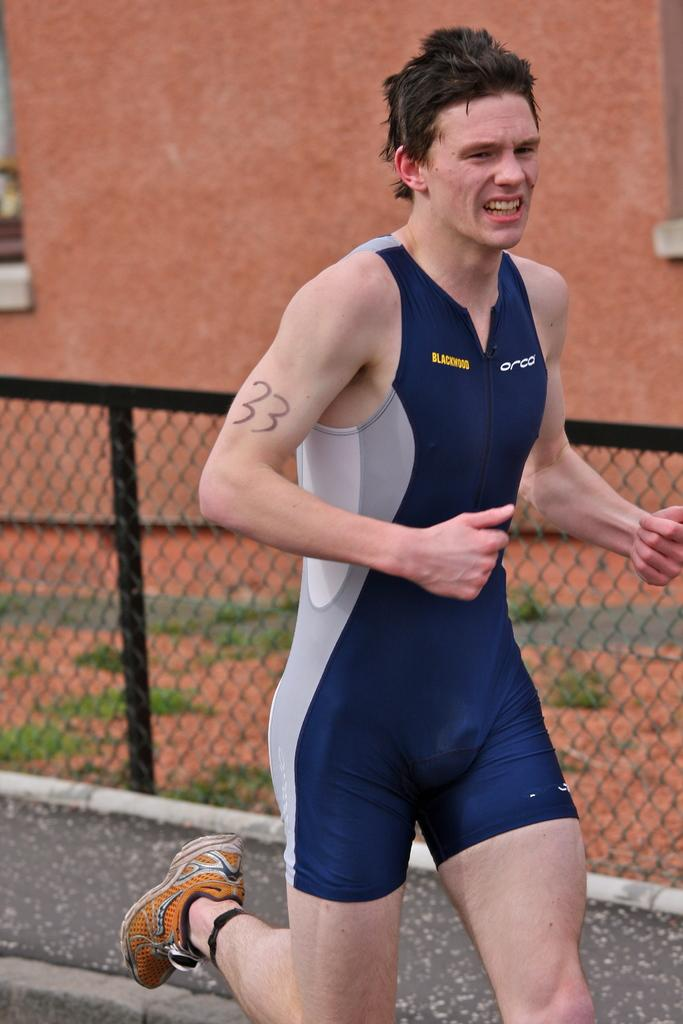What is the main subject in the image? There is a person standing on the road. What can be seen in the background of the image? There is a building behind the person. Where is the lake located in the image? There is no lake present in the image. What type of force is being applied to the person in the image? There is no force being applied to the person in the image; they are standing still. 